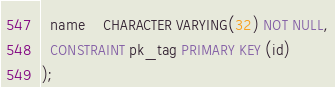<code> <loc_0><loc_0><loc_500><loc_500><_SQL_>  name    CHARACTER VARYING(32) NOT NULL,
  CONSTRAINT pk_tag PRIMARY KEY (id)
);</code> 